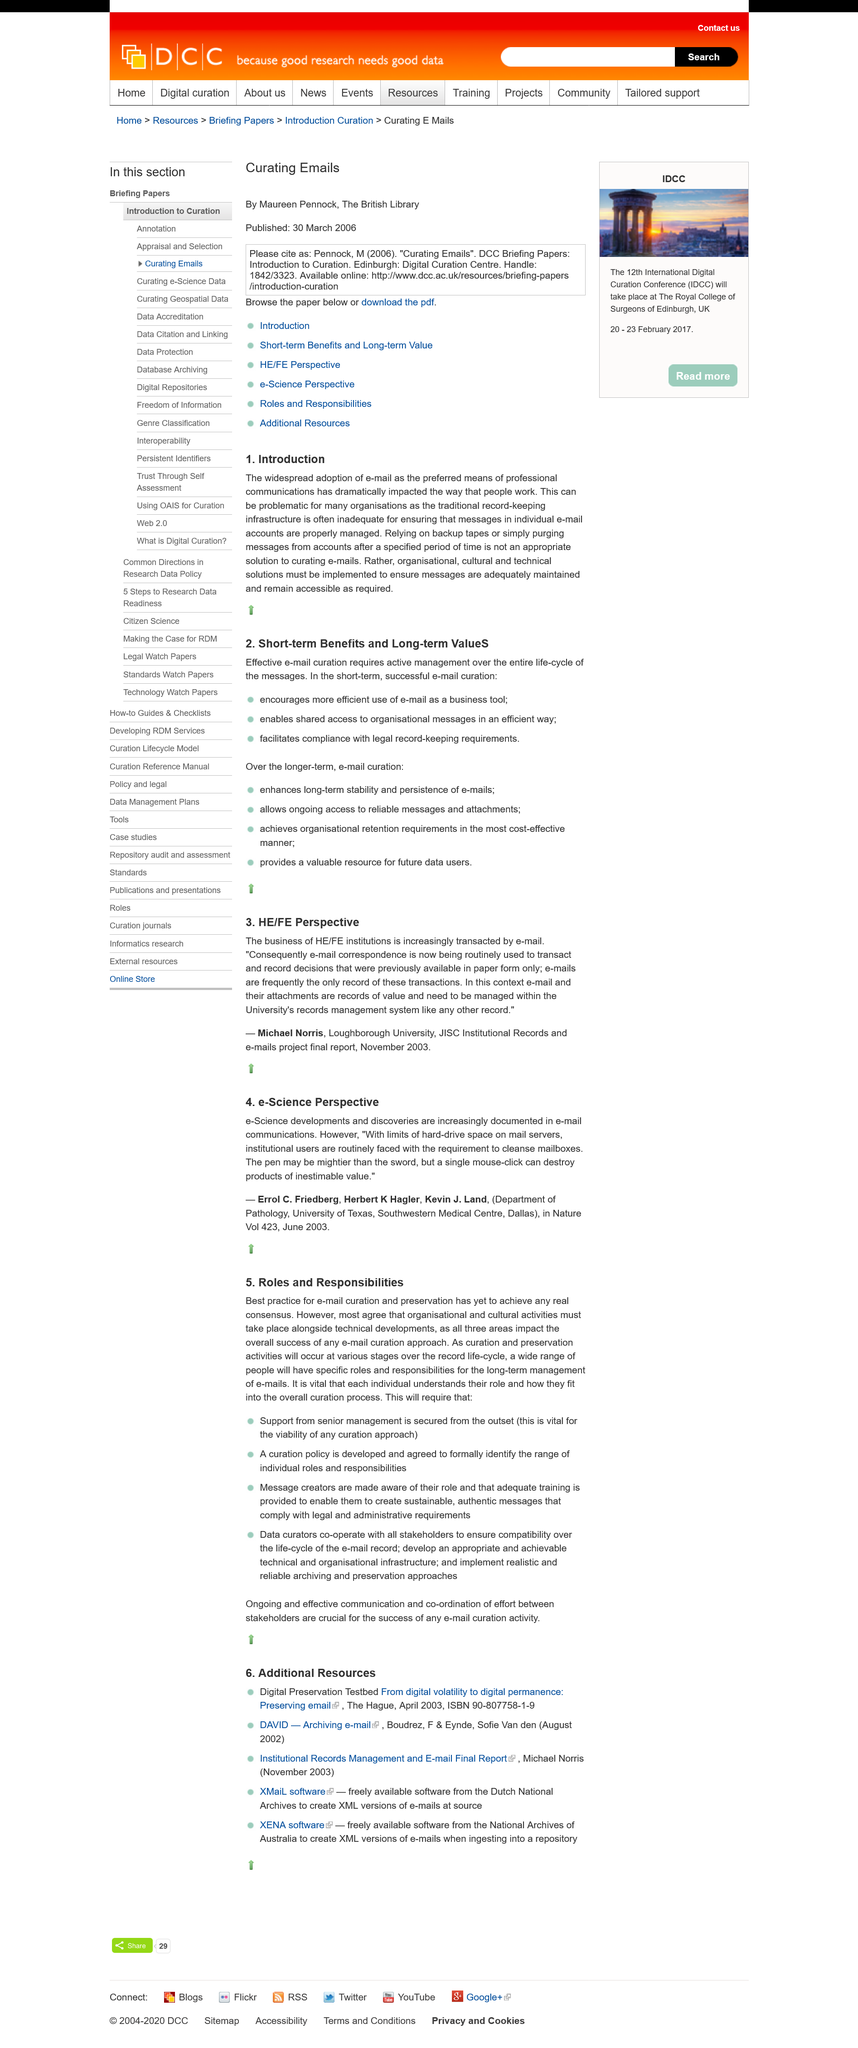Point out several critical features in this image. The widespread use of e-mail can be problematic for many organizations, as they must ensure that each individual email is properly managed to avoid potential issues. Errol C. Friedberg, Herbert K. Hagler, and Kevin J. Land have been cited as the authors of the quote. E-Science developments and discoveries are increasingly being documented in email communications. The adoption of email has become widespread, and it is now widely used. The title of this subheading is "HE/FE Perspective". 